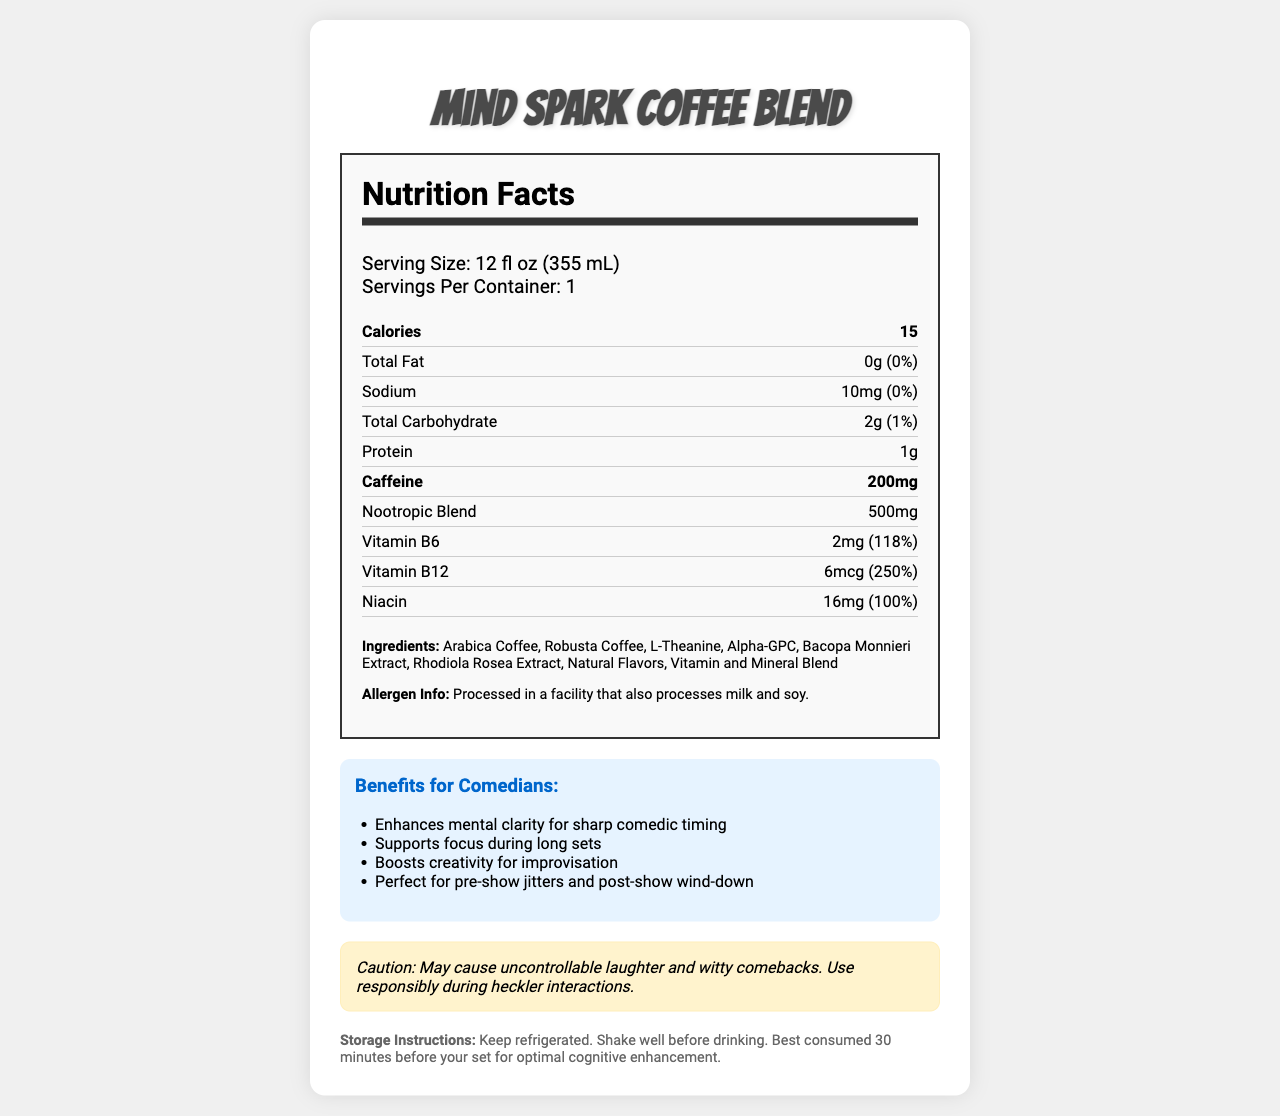what is the serving size for the Mind Spark Coffee Blend? The serving size is directly listed as "12 fl oz (355 mL)".
Answer: 12 fl oz (355 mL) how many calories are in one serving? The document specifies the amount of calories as 15.
Answer: 15 calories how much caffeine does one serving contain? The caffeine content is listed as 200mg per serving.
Answer: 200mg which vitamins are included in the Mind Spark Coffee Blend? The vitamins listed in the document are Vitamin B6, Vitamin B12, and Niacin.
Answer: Vitamin B6, Vitamin B12, Niacin how much protein is in one serving? The protein content for each serving is 1g as mentioned in the document.
Answer: 1g what is the daily value percentage of Vitamin B6? For Vitamin B6, the daily value percentage is 118%.
Answer: 118% how many total carbohydrates are in one serving? A. 0g B. 1g C. 2g D. 3g The total carbohydrate amount is listed as 2g.
Answer: C what ingredient is not part of the nootropic blend? A. L-Theanine B. Bacopa Monnieri Extract C. Niacin D. Alpha-GPC Niacin is not part of the nootropic blend; it is a vitamin included separately.
Answer: C is the Mind Spark Coffee Blend processed in a facility that handles milk and soy? It states that it is processed in a facility that also processes milk and soy.
Answer: Yes describe the main features and benefits of the Mind Spark Coffee Blend document. The document covers the nutrition facts, lists the ingredients, allergen information, benefits related to cognitive functions, a comedic caution, and storage instructions.
Answer: The document provides detailed nutrition facts and ingredients of the Mind Spark Coffee Blend, emphasizing its added nootropics such as L-Theanine and Alpha-GPC. It includes nutritional content like calories, fats, carbohydrates, proteins, vitamins, and caffeine content. Key benefits highlighted relate to mental clarity, focus, creativity, and calming effects, which are particularly marketed towards comedians. The document also includes a humorous warning regarding potential side effects and storage instructions. what is the exact percentage of the daily value for sodium? The daily value percentage for sodium is listed as 0%.
Answer: 0% what is the recommended time to consume Mind Spark Coffee Blend before a comedy set for optimal cognitive enhancement? It is recommended to consume the coffee 30 minutes before your set for optimal cognitive enhancement.
Answer: 30 minutes before your set which ingredient in the Mind Spark Coffee Blend is responsible for its primary stimulant effects? Caffeine, listed at 200mg per serving, is known for its stimulant effects.
Answer: Caffeine what is the main comedic benefit claimed for the Mind Spark Coffee Blend? One of the key claims is that it enhances mental clarity for sharp comedic timing.
Answer: Enhances mental clarity for sharp comedic timing what is the exact amount of Bacopa Monnieri Extract in the nootropic blend? The document provides an overall total for the nootropic blend but does not specify individual amounts for each ingredient.
Answer: Cannot be determined which vitamin has the highest daily value percentage? Vitamin B12 has a daily value percentage of 250%, the highest among the listed vitamins.
Answer: Vitamin B12 what is the comedic warning mentioned in the document? The document humorously warns that the product may cause uncontrollable laughter and witty comebacks, advising responsible use during heckler interactions.
Answer: Caution: May cause uncontrollable laughter and witty comebacks. Use responsibly during heckler interactions. 